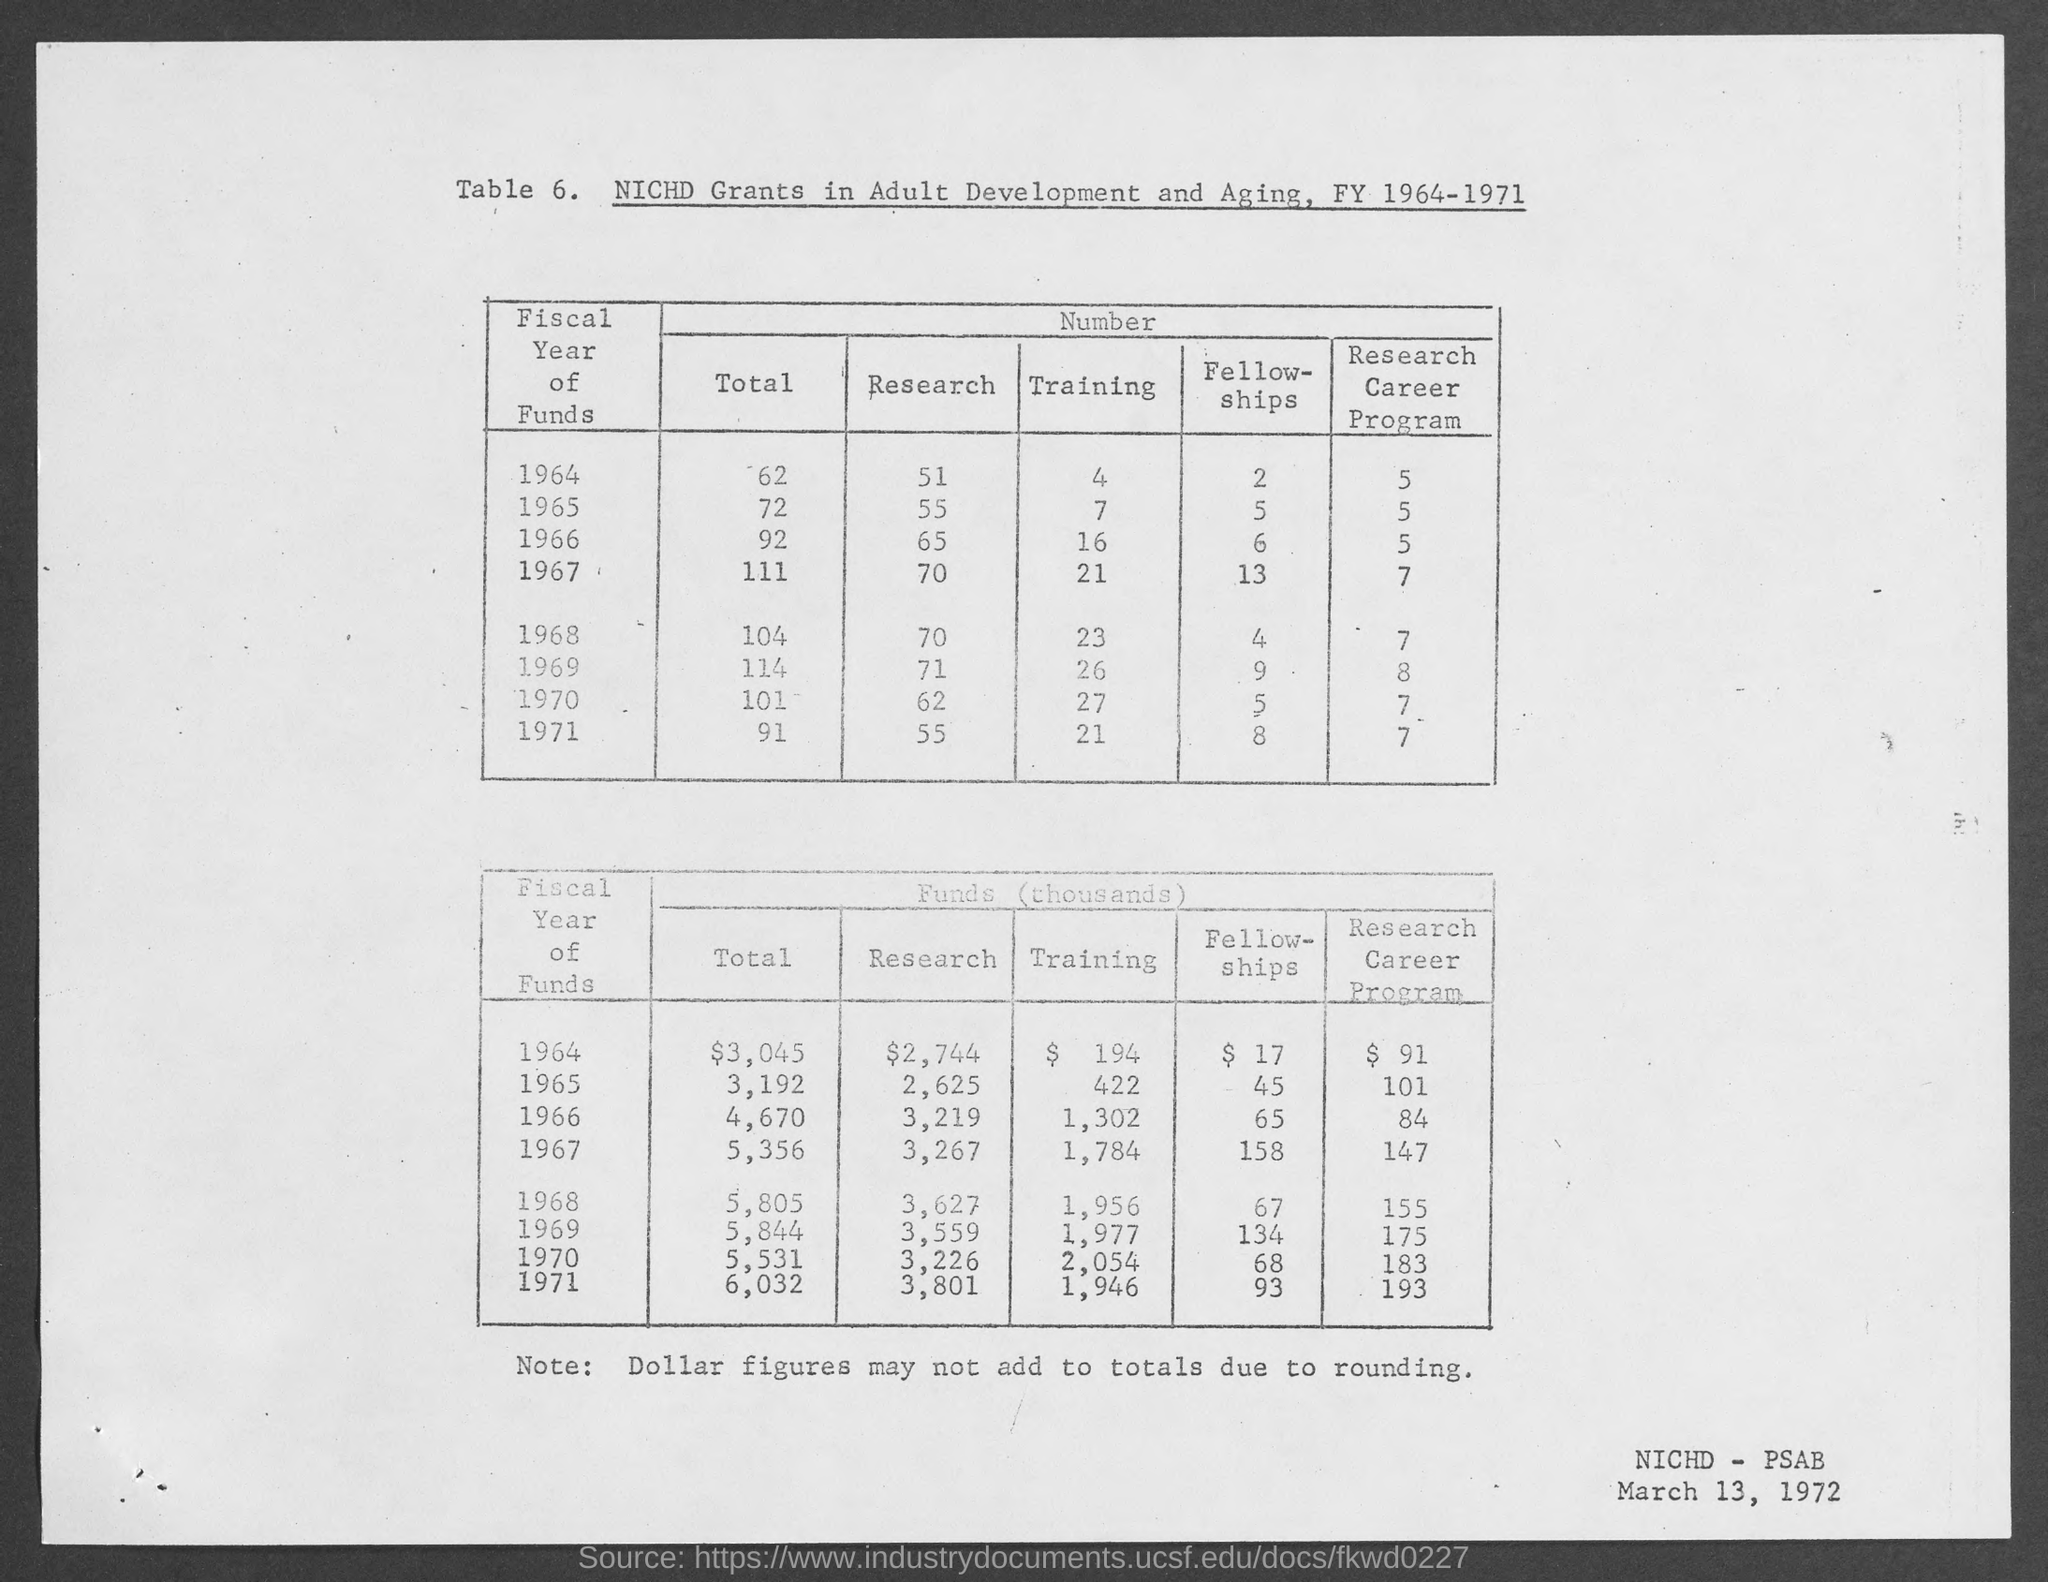What is the total value of funds in the year 1964 ?
Offer a terse response. $3,045. What is the total value of funds in the year 1965 ?
Offer a very short reply. 3,192. What is the total value of funds in the year 1966 ?
Your response must be concise. 4,670. What is the total value of funds in the year 1967 ?
Offer a terse response. 5,356. What is the total value of funds in the year 1968 ?
Your answer should be very brief. 5,805. What is the total value of funds in the year 1969 ?
Give a very brief answer. 5,844. What is the total value of funds in the year 1970 ?
Provide a short and direct response. 5,531. What is the total value of funds in the year 1971 ?
Give a very brief answer. 6,032. What is the amount of fund for research in the year 1964 as mentioned in the given table ?
Make the answer very short. $2,744. What is the amount of fund for research in the year 1965 as mentioned in the given table ?
Provide a succinct answer. 2,625. 